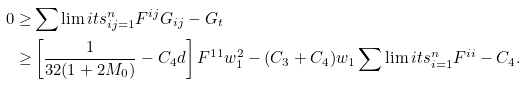<formula> <loc_0><loc_0><loc_500><loc_500>0 \geq & \sum \lim i t s _ { i j = 1 } ^ { n } { F ^ { i j } G _ { i j } } - G _ { t } \\ \geq & \left [ \frac { 1 } { 3 2 ( 1 + 2 M _ { 0 } ) } - C _ { 4 } d \right ] F ^ { 1 1 } w _ { 1 } ^ { 2 } - ( C _ { 3 } + C _ { 4 } ) w _ { 1 } \sum \lim i t s _ { i = 1 } ^ { n } { F ^ { i i } } - C _ { 4 } .</formula> 